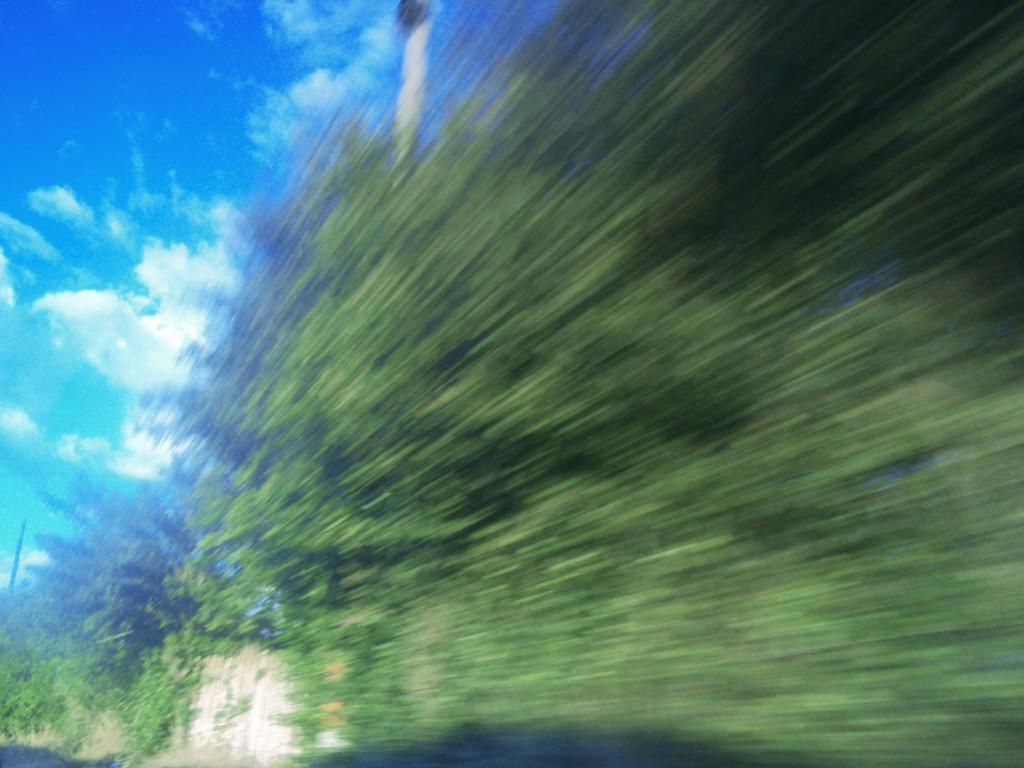What is located in the center of the image? There are trees in the center of the image. What is visible at the top of the image? The sky is visible at the top of the image. What type of structure can be seen in the image? There is a wall in the image. Can you see any kites flying in the image? There is no kite present in the image. Where is the lunchroom located in the image? There is no mention of a lunchroom in the image, so its location cannot be determined. 